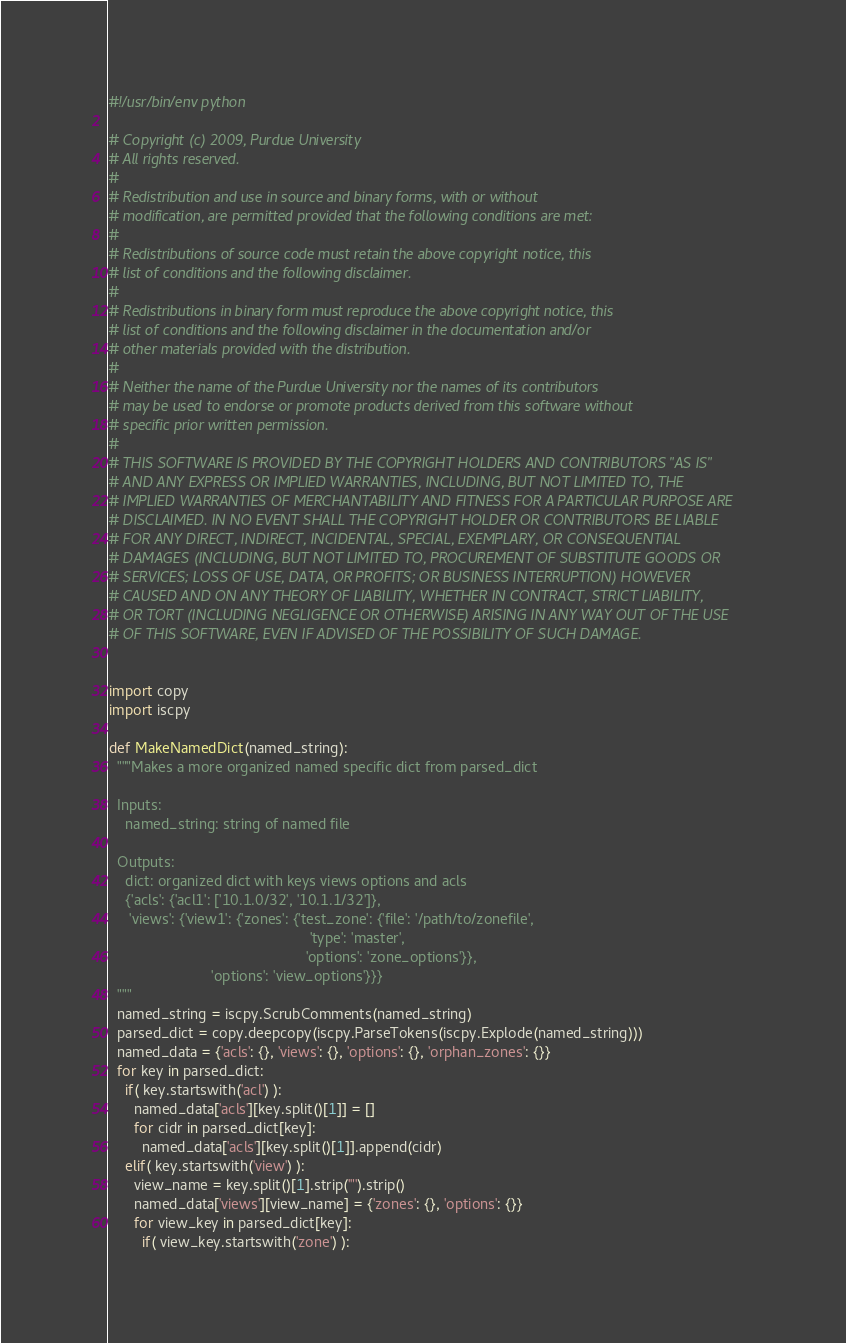Convert code to text. <code><loc_0><loc_0><loc_500><loc_500><_Python_>#!/usr/bin/env python

# Copyright (c) 2009, Purdue University
# All rights reserved.
#
# Redistribution and use in source and binary forms, with or without
# modification, are permitted provided that the following conditions are met:
#
# Redistributions of source code must retain the above copyright notice, this
# list of conditions and the following disclaimer.
#
# Redistributions in binary form must reproduce the above copyright notice, this
# list of conditions and the following disclaimer in the documentation and/or
# other materials provided with the distribution.
#
# Neither the name of the Purdue University nor the names of its contributors
# may be used to endorse or promote products derived from this software without
# specific prior written permission.
#
# THIS SOFTWARE IS PROVIDED BY THE COPYRIGHT HOLDERS AND CONTRIBUTORS "AS IS"
# AND ANY EXPRESS OR IMPLIED WARRANTIES, INCLUDING, BUT NOT LIMITED TO, THE
# IMPLIED WARRANTIES OF MERCHANTABILITY AND FITNESS FOR A PARTICULAR PURPOSE ARE
# DISCLAIMED. IN NO EVENT SHALL THE COPYRIGHT HOLDER OR CONTRIBUTORS BE LIABLE
# FOR ANY DIRECT, INDIRECT, INCIDENTAL, SPECIAL, EXEMPLARY, OR CONSEQUENTIAL
# DAMAGES (INCLUDING, BUT NOT LIMITED TO, PROCUREMENT OF SUBSTITUTE GOODS OR
# SERVICES; LOSS OF USE, DATA, OR PROFITS; OR BUSINESS INTERRUPTION) HOWEVER
# CAUSED AND ON ANY THEORY OF LIABILITY, WHETHER IN CONTRACT, STRICT LIABILITY,
# OR TORT (INCLUDING NEGLIGENCE OR OTHERWISE) ARISING IN ANY WAY OUT OF THE USE
# OF THIS SOFTWARE, EVEN IF ADVISED OF THE POSSIBILITY OF SUCH DAMAGE.


import copy
import iscpy

def MakeNamedDict(named_string):
  """Makes a more organized named specific dict from parsed_dict

  Inputs:
    named_string: string of named file

  Outputs:
    dict: organized dict with keys views options and acls
    {'acls': {'acl1': ['10.1.0/32', '10.1.1/32']},
     'views': {'view1': {'zones': {'test_zone': {'file': '/path/to/zonefile',
                                                 'type': 'master',
                                                'options': 'zone_options'}},
                         'options': 'view_options'}}}
  """
  named_string = iscpy.ScrubComments(named_string)
  parsed_dict = copy.deepcopy(iscpy.ParseTokens(iscpy.Explode(named_string)))
  named_data = {'acls': {}, 'views': {}, 'options': {}, 'orphan_zones': {}}
  for key in parsed_dict:
    if( key.startswith('acl') ):
      named_data['acls'][key.split()[1]] = []
      for cidr in parsed_dict[key]:
        named_data['acls'][key.split()[1]].append(cidr)
    elif( key.startswith('view') ):
      view_name = key.split()[1].strip('"').strip()
      named_data['views'][view_name] = {'zones': {}, 'options': {}}
      for view_key in parsed_dict[key]:
        if( view_key.startswith('zone') ):</code> 